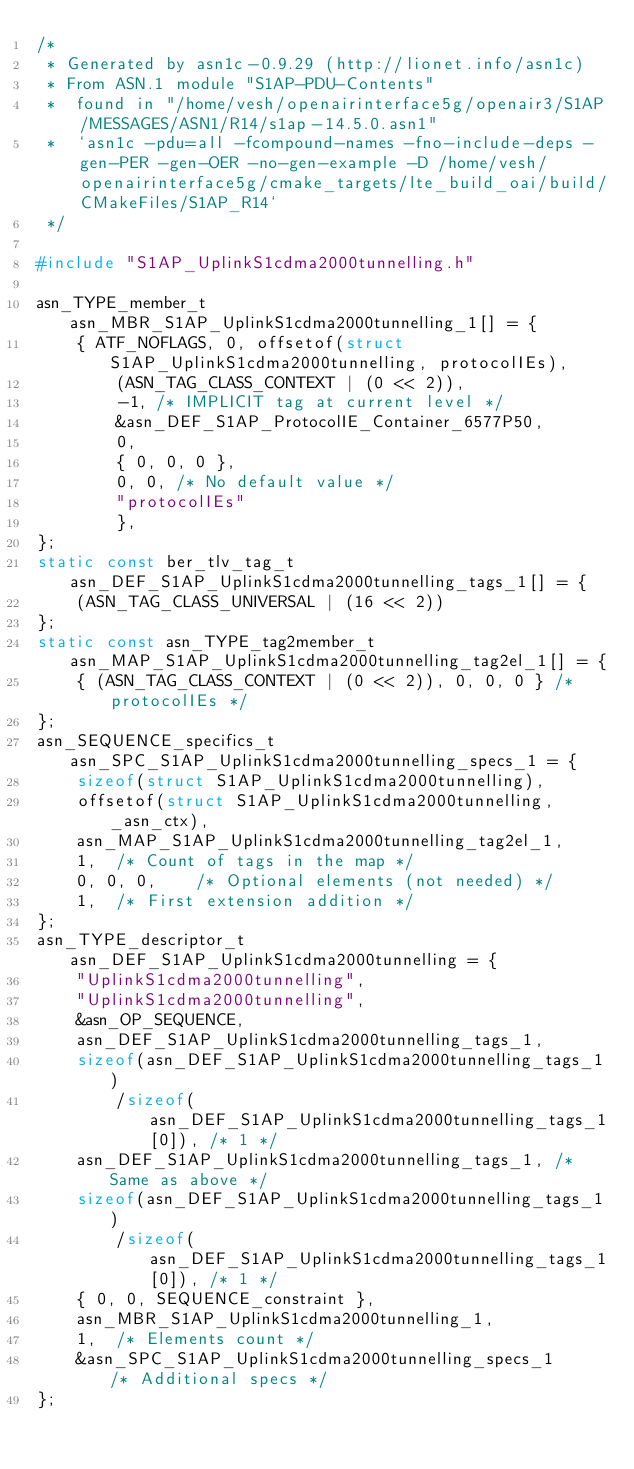Convert code to text. <code><loc_0><loc_0><loc_500><loc_500><_C_>/*
 * Generated by asn1c-0.9.29 (http://lionet.info/asn1c)
 * From ASN.1 module "S1AP-PDU-Contents"
 * 	found in "/home/vesh/openairinterface5g/openair3/S1AP/MESSAGES/ASN1/R14/s1ap-14.5.0.asn1"
 * 	`asn1c -pdu=all -fcompound-names -fno-include-deps -gen-PER -gen-OER -no-gen-example -D /home/vesh/openairinterface5g/cmake_targets/lte_build_oai/build/CMakeFiles/S1AP_R14`
 */

#include "S1AP_UplinkS1cdma2000tunnelling.h"

asn_TYPE_member_t asn_MBR_S1AP_UplinkS1cdma2000tunnelling_1[] = {
	{ ATF_NOFLAGS, 0, offsetof(struct S1AP_UplinkS1cdma2000tunnelling, protocolIEs),
		(ASN_TAG_CLASS_CONTEXT | (0 << 2)),
		-1,	/* IMPLICIT tag at current level */
		&asn_DEF_S1AP_ProtocolIE_Container_6577P50,
		0,
		{ 0, 0, 0 },
		0, 0, /* No default value */
		"protocolIEs"
		},
};
static const ber_tlv_tag_t asn_DEF_S1AP_UplinkS1cdma2000tunnelling_tags_1[] = {
	(ASN_TAG_CLASS_UNIVERSAL | (16 << 2))
};
static const asn_TYPE_tag2member_t asn_MAP_S1AP_UplinkS1cdma2000tunnelling_tag2el_1[] = {
    { (ASN_TAG_CLASS_CONTEXT | (0 << 2)), 0, 0, 0 } /* protocolIEs */
};
asn_SEQUENCE_specifics_t asn_SPC_S1AP_UplinkS1cdma2000tunnelling_specs_1 = {
	sizeof(struct S1AP_UplinkS1cdma2000tunnelling),
	offsetof(struct S1AP_UplinkS1cdma2000tunnelling, _asn_ctx),
	asn_MAP_S1AP_UplinkS1cdma2000tunnelling_tag2el_1,
	1,	/* Count of tags in the map */
	0, 0, 0,	/* Optional elements (not needed) */
	1,	/* First extension addition */
};
asn_TYPE_descriptor_t asn_DEF_S1AP_UplinkS1cdma2000tunnelling = {
	"UplinkS1cdma2000tunnelling",
	"UplinkS1cdma2000tunnelling",
	&asn_OP_SEQUENCE,
	asn_DEF_S1AP_UplinkS1cdma2000tunnelling_tags_1,
	sizeof(asn_DEF_S1AP_UplinkS1cdma2000tunnelling_tags_1)
		/sizeof(asn_DEF_S1AP_UplinkS1cdma2000tunnelling_tags_1[0]), /* 1 */
	asn_DEF_S1AP_UplinkS1cdma2000tunnelling_tags_1,	/* Same as above */
	sizeof(asn_DEF_S1AP_UplinkS1cdma2000tunnelling_tags_1)
		/sizeof(asn_DEF_S1AP_UplinkS1cdma2000tunnelling_tags_1[0]), /* 1 */
	{ 0, 0, SEQUENCE_constraint },
	asn_MBR_S1AP_UplinkS1cdma2000tunnelling_1,
	1,	/* Elements count */
	&asn_SPC_S1AP_UplinkS1cdma2000tunnelling_specs_1	/* Additional specs */
};

</code> 